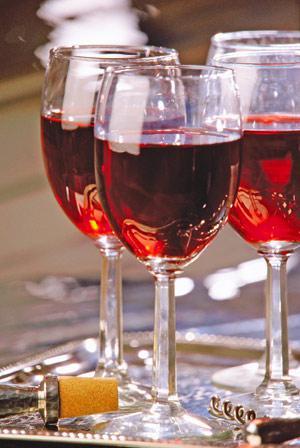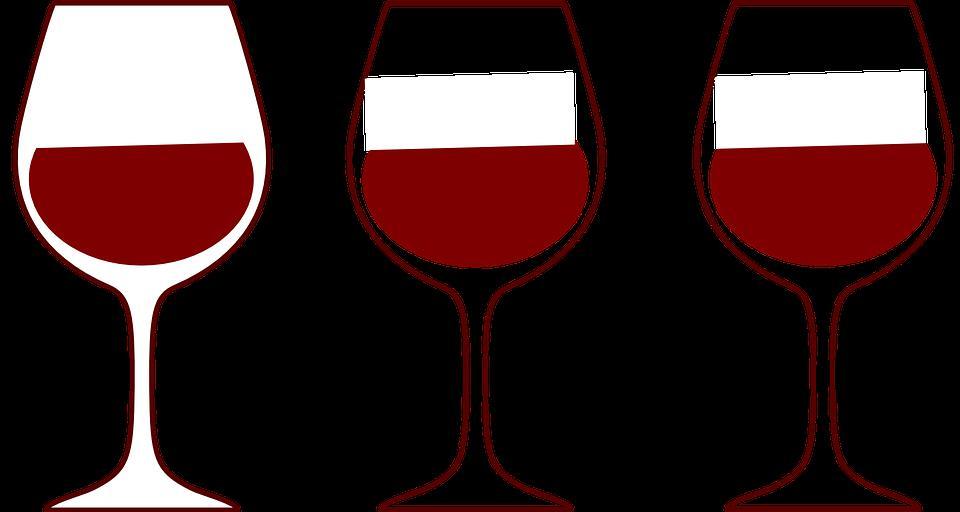The first image is the image on the left, the second image is the image on the right. Given the left and right images, does the statement "An image includes a trio of stemmed glasses all containing red wine, with the middle glass in front of the other two." hold true? Answer yes or no. Yes. 